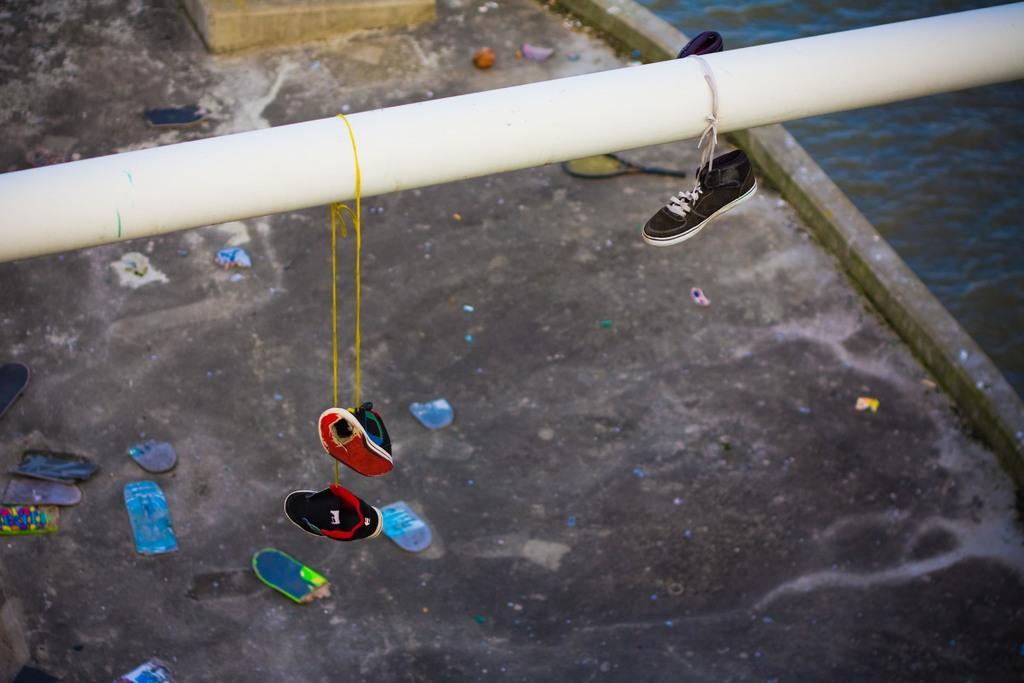Can you describe this image briefly? To this pipe there are shoes. On the ground we can see things. Right side corner of the image there is water. 